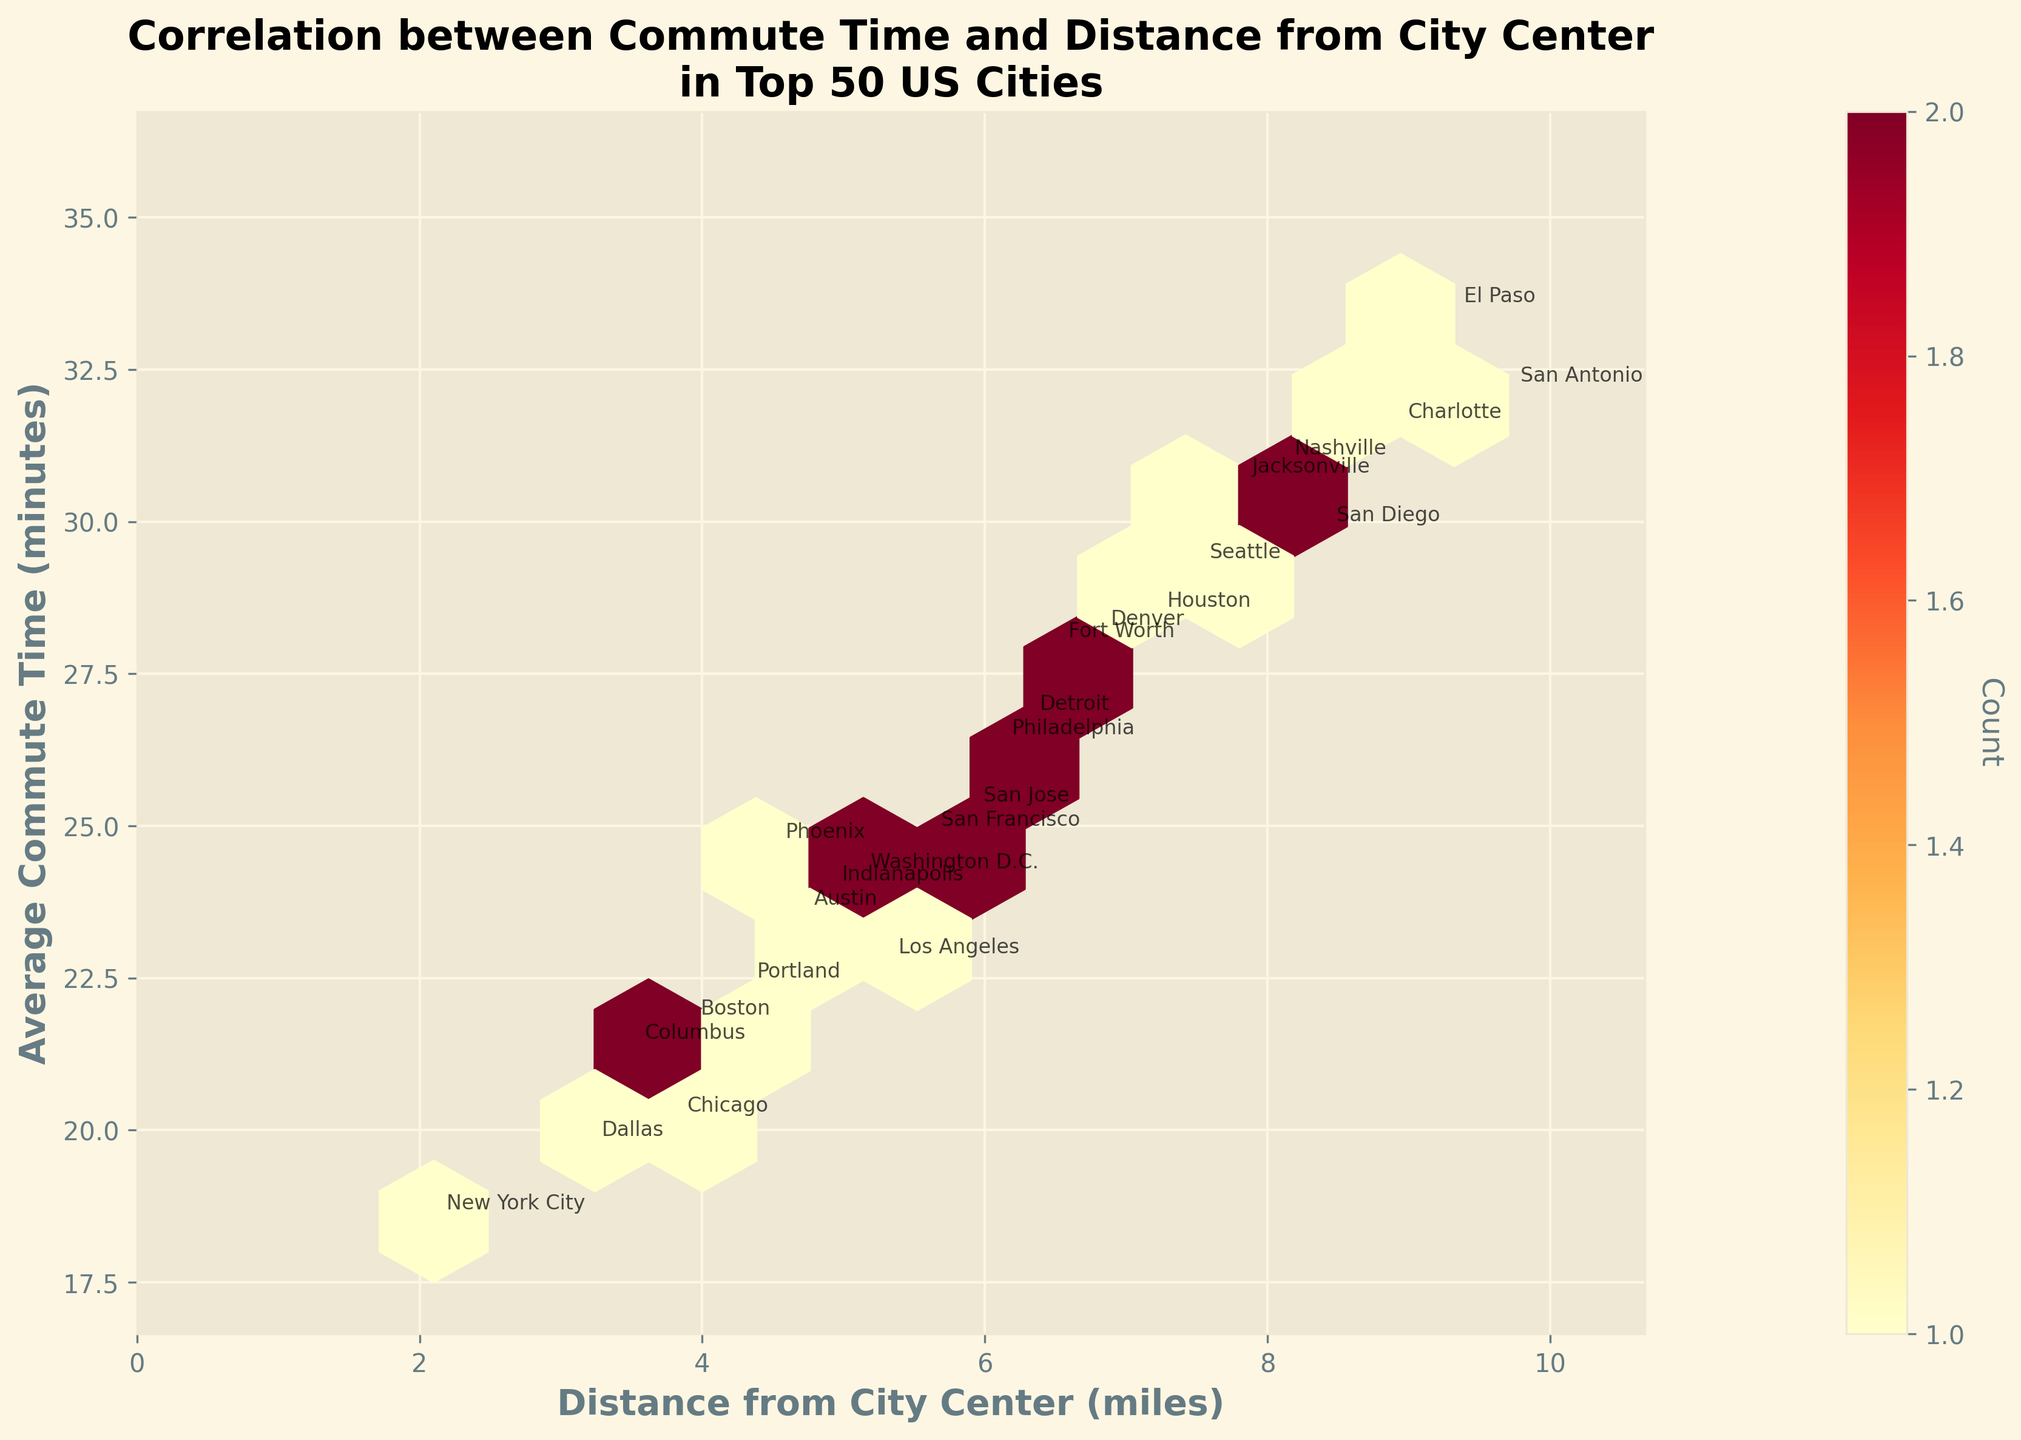What is the title of the Hexbin plot? The title is at the top of the figure. It reads 'Correlation between Commute Time and Distance from City Center\nin Top 50 US Cities'.
Answer: Correlation between Commute Time and Distance from City Center in Top 50 US Cities What are the axes labels in the plot? The x-axis is labeled 'Distance from City Center (miles)', and the y-axis is labeled 'Average Commute Time (minutes)'. Both labels are bolded and clear.
Answer: Distance from City Center (miles) and Average Commute Time (minutes) Which city is located furthest from its city center? El Paso is annotated at the far right, corresponding to a distance of 9.3 miles from the city center.
Answer: El Paso Which city has the maximum average commute time? The city with the highest average commute time is El Paso, annotated at the top right corner with an average of 33.4 minutes.
Answer: El Paso How many bins in the plot represent at least one data point? You need to look at the hexagons in the plot and determine the colored ones, which represent one or more data points.
Answer: 10 Is there a general trend between commute time and distance from the city center? Observing the plot, as the distance from the city center increases, the average commute time also tends to increase.
Answer: Yes Which city is closer to the city center, Dallas or Phoenix, and what are their distances? Dallas is marked closer to the origin at approximately 3.2 miles, while Phoenix is at 4.5 miles from the city center.
Answer: Dallas (3.2 miles) is closer than Phoenix (4.5 miles) Which city has a shorter commute time, Seattle or Philadelphia? Seattle has an average commute time of 29.2 minutes, while Philadelphia has 26.3 minutes. Philadelphia's commute time is shorter.
Answer: Philadelphia Are there any cities with an average commute time below 20 minutes? If so, which ones? Yes, New York City and Dallas are below 20 minutes, with average commute times of 18.5 and 19.7 minutes respectively.
Answer: New York City, Dallas Compare the commute times of San Antonio and San Diego. Which city has a higher commute time? San Antonio has an average commute time of 32.1 minutes compared to San Diego’s 29.8 minutes. Hence, San Antonio has a higher commute time.
Answer: San Antonio 